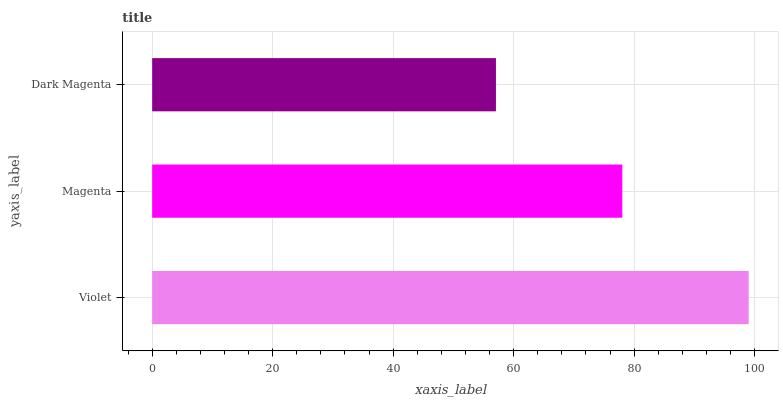Is Dark Magenta the minimum?
Answer yes or no. Yes. Is Violet the maximum?
Answer yes or no. Yes. Is Magenta the minimum?
Answer yes or no. No. Is Magenta the maximum?
Answer yes or no. No. Is Violet greater than Magenta?
Answer yes or no. Yes. Is Magenta less than Violet?
Answer yes or no. Yes. Is Magenta greater than Violet?
Answer yes or no. No. Is Violet less than Magenta?
Answer yes or no. No. Is Magenta the high median?
Answer yes or no. Yes. Is Magenta the low median?
Answer yes or no. Yes. Is Dark Magenta the high median?
Answer yes or no. No. Is Dark Magenta the low median?
Answer yes or no. No. 